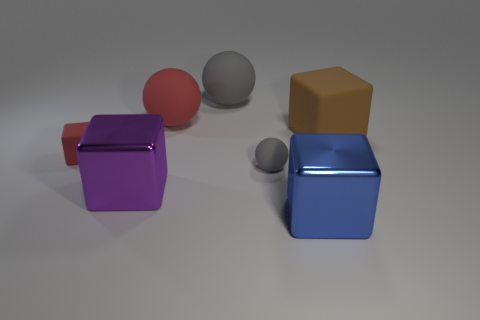Subtract all big matte spheres. How many spheres are left? 1 Add 2 gray metal cubes. How many objects exist? 9 Subtract 1 cubes. How many cubes are left? 3 Subtract all gray balls. How many balls are left? 1 Add 6 brown blocks. How many brown blocks are left? 7 Add 3 large blue metallic things. How many large blue metallic things exist? 4 Subtract 0 yellow cylinders. How many objects are left? 7 Subtract all balls. How many objects are left? 4 Subtract all yellow balls. Subtract all blue blocks. How many balls are left? 3 Subtract all gray balls. How many brown blocks are left? 1 